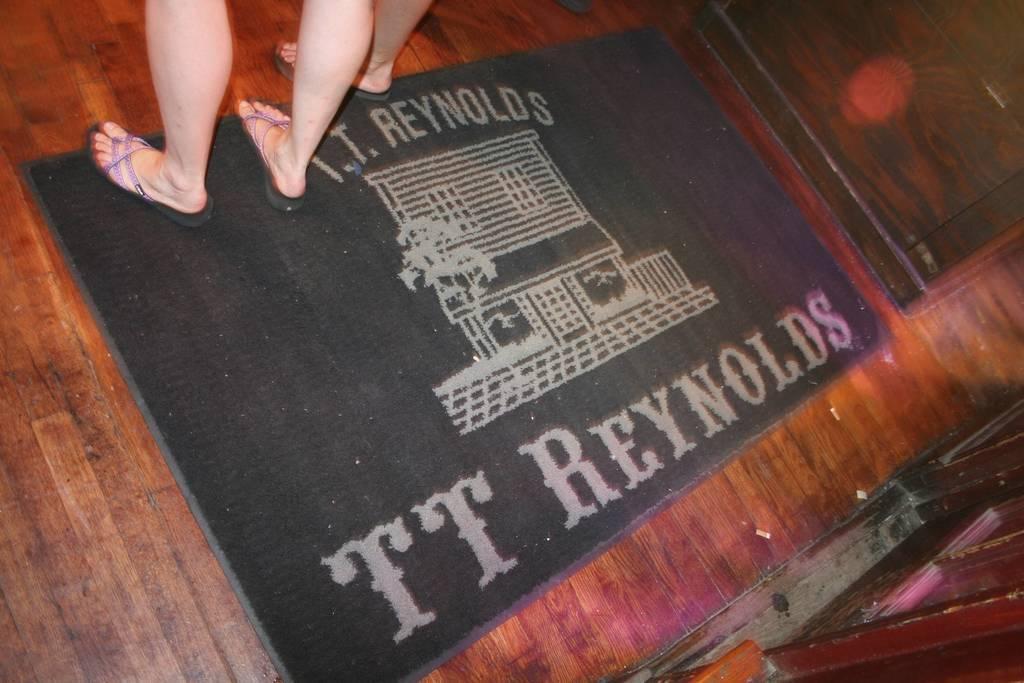Could you give a brief overview of what you see in this image? In this image we can see legs of people on the carpet. At the bottom of the image there is wooden flooring. 